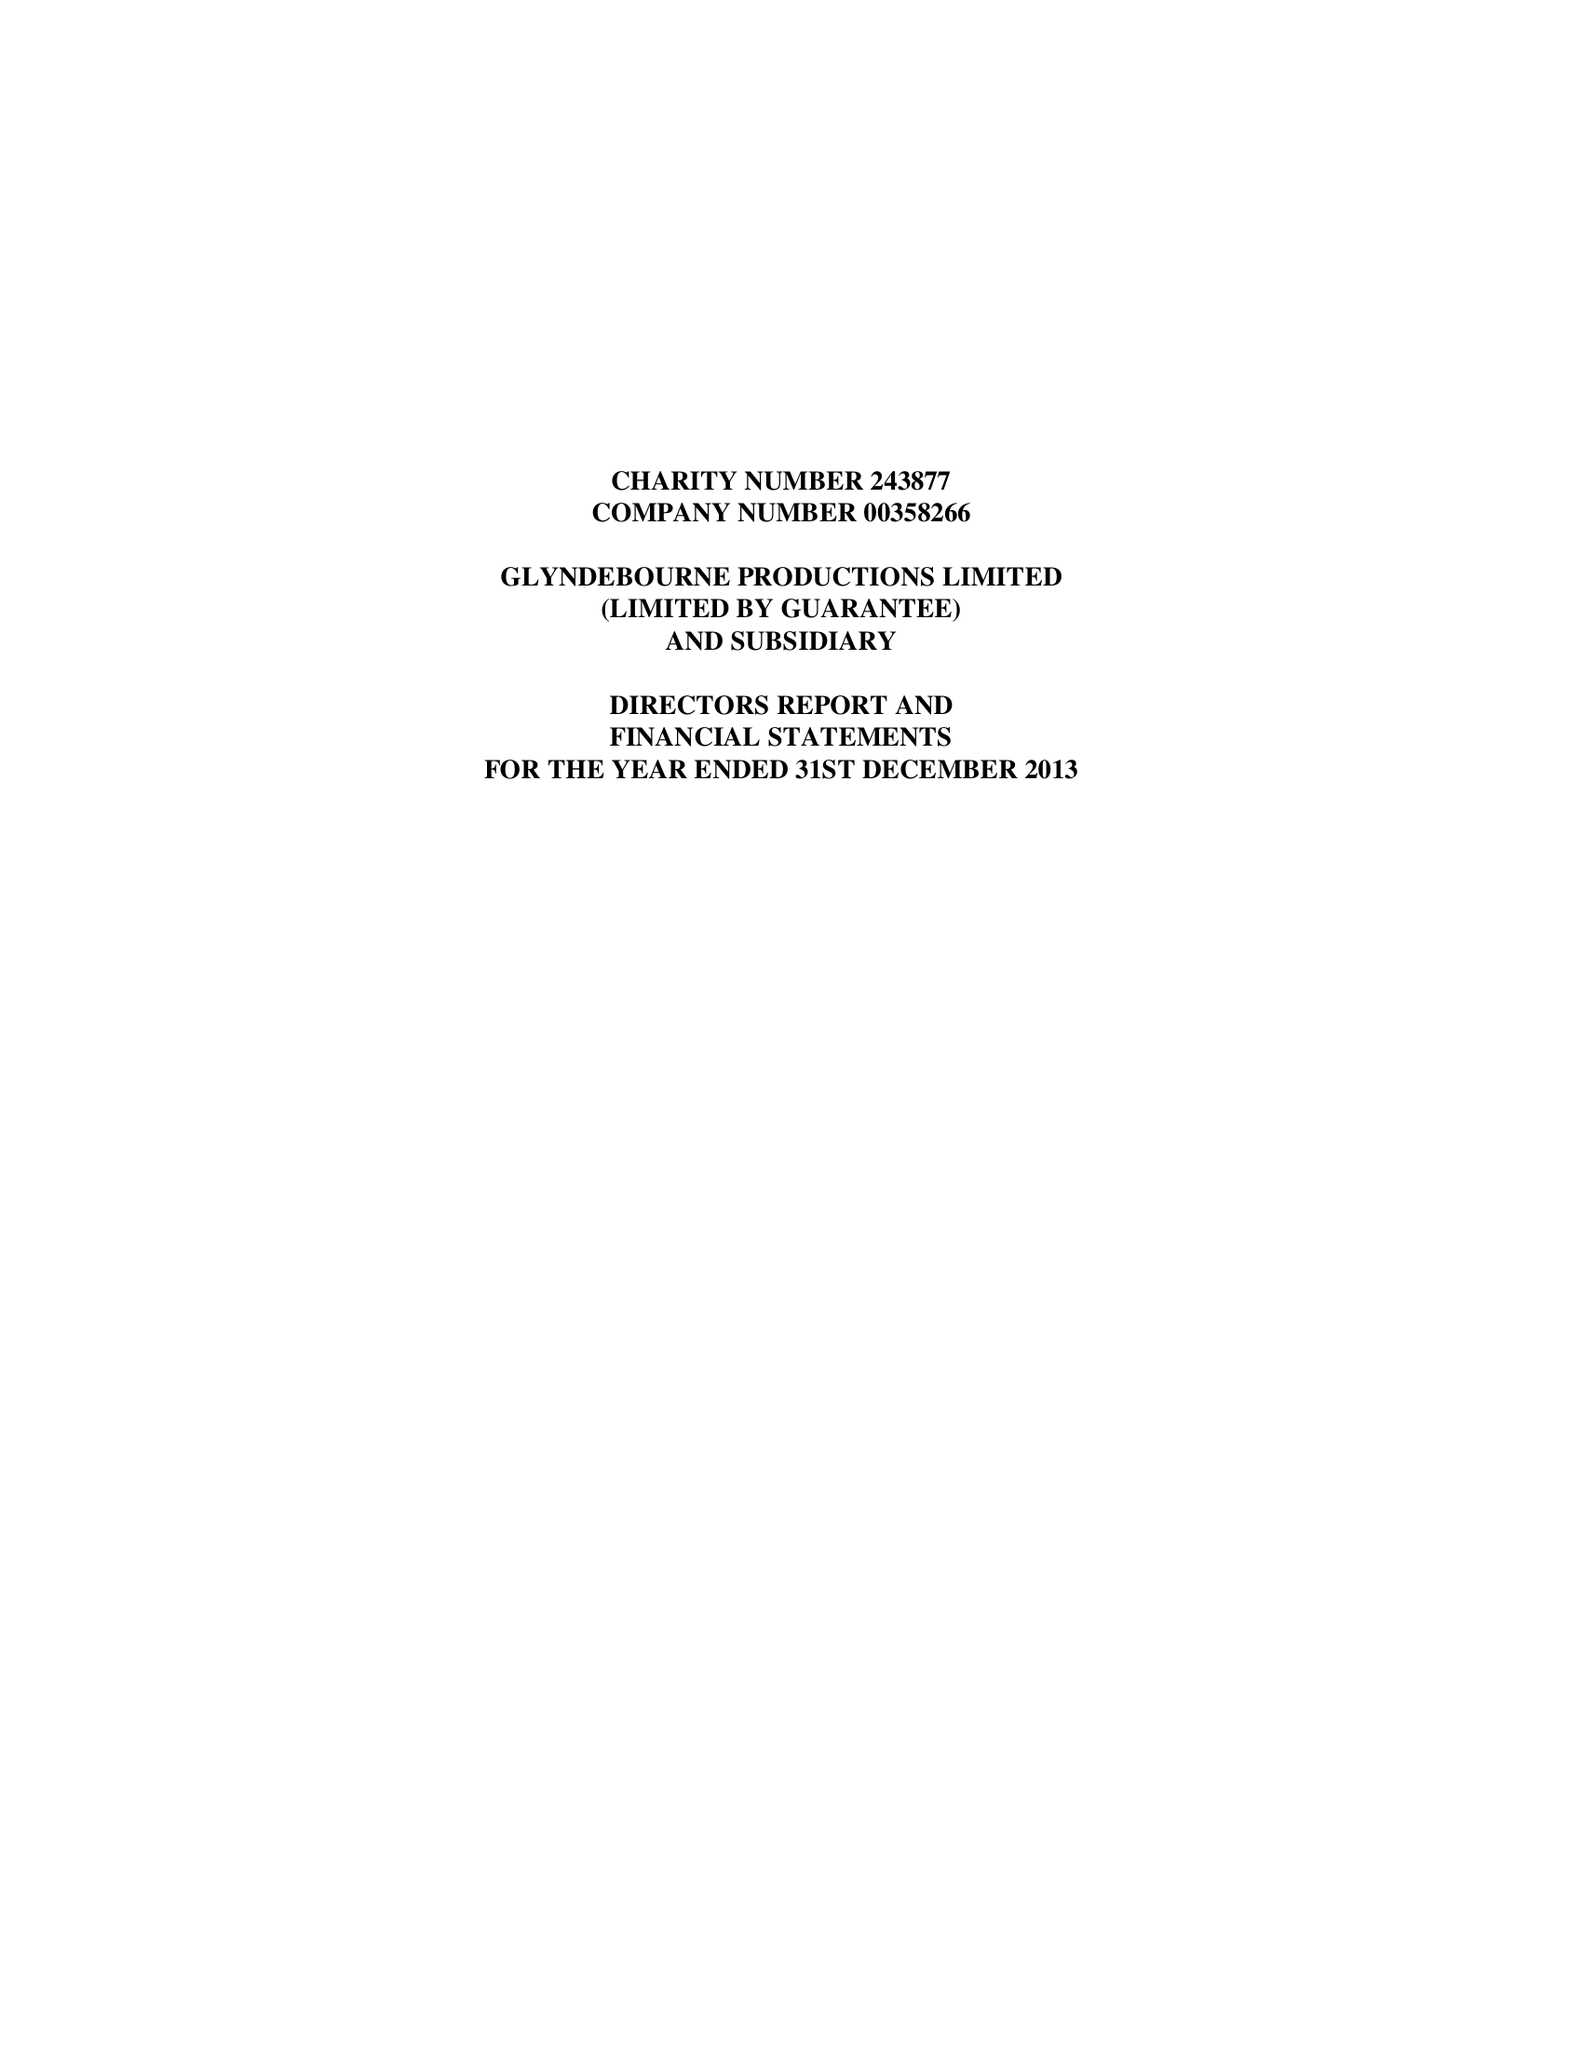What is the value for the report_date?
Answer the question using a single word or phrase. 2013-12-31 